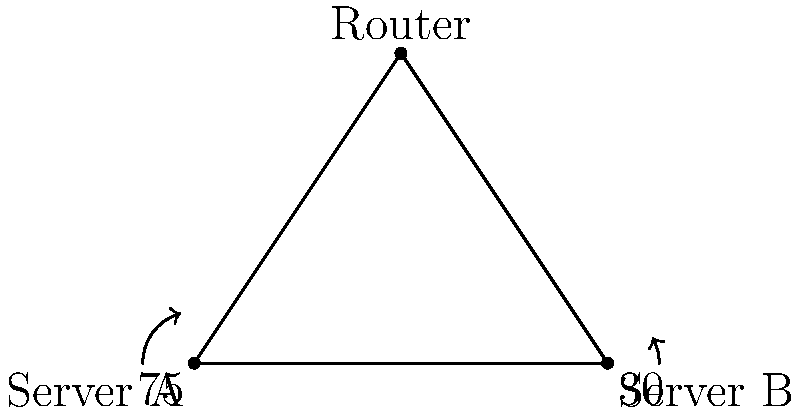In a network diagram, Server A and Server B are connected through a central Router. The angle between Server A and the Router is 75°, and the angle between Server B and the Router is 30°. What is the angle between Server A and Server B? To find the angle between Server A and Server B, we can follow these steps:

1. In a triangle, the sum of all interior angles is always 180°.

2. Let's call the angle we're looking for (between Server A and Server B) as x°.

3. We can set up an equation based on the fact that all angles in a triangle sum to 180°:
   $75° + 30° + x° = 180°$

4. Simplify the left side of the equation:
   $105° + x° = 180°$

5. Subtract 105° from both sides:
   $x° = 180° - 105°$

6. Solve for x:
   $x° = 75°$

Therefore, the angle between Server A and Server B is 75°.
Answer: 75° 